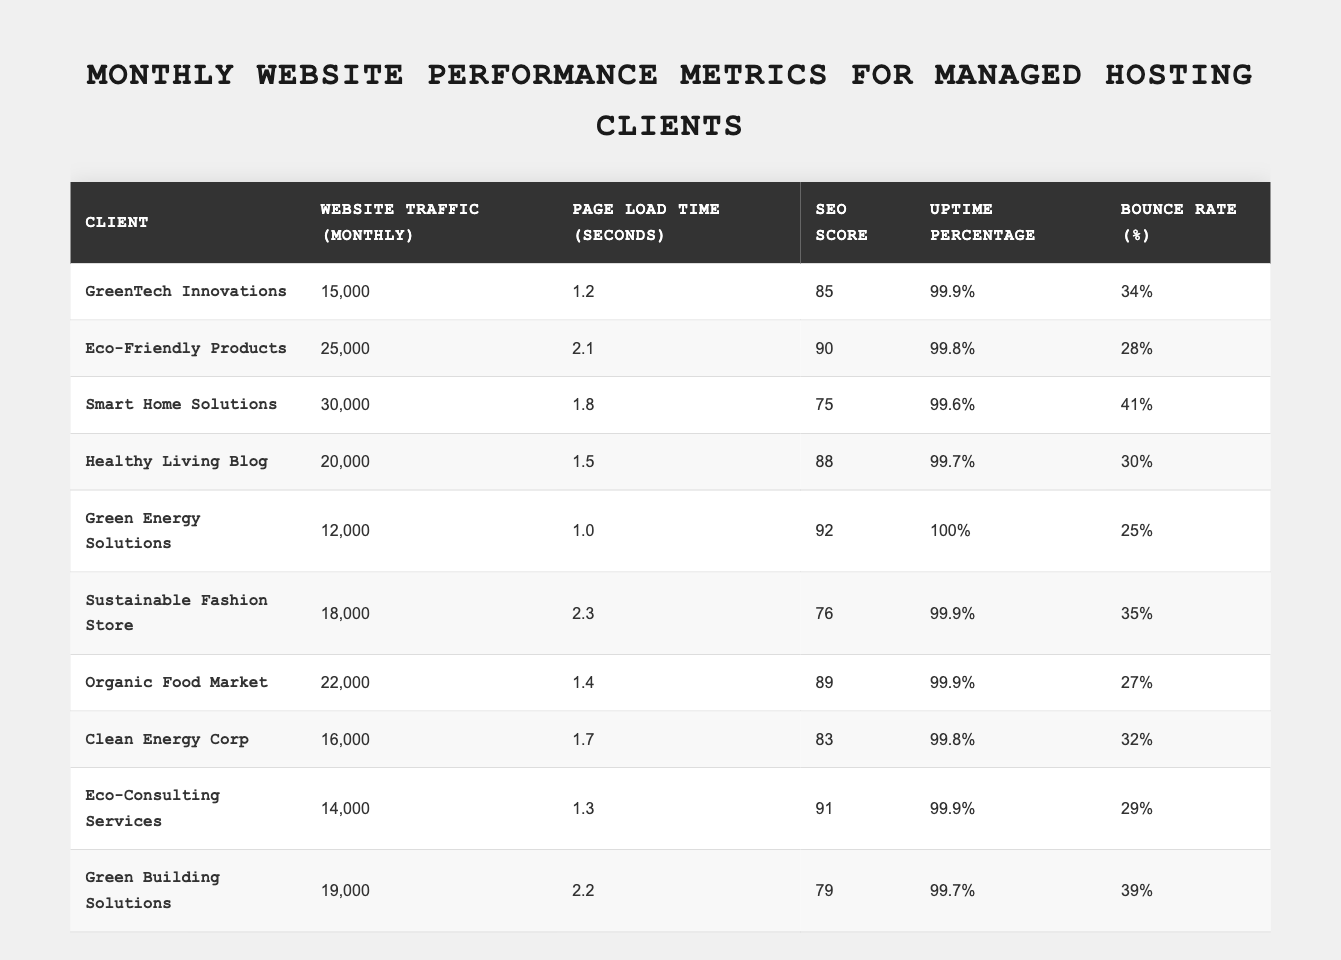What is the website traffic for GreenTech Innovations? The table lists the website traffic for GreenTech Innovations as 15,000.
Answer: 15,000 Which client has the highest SEO score? By looking at the SEO score column, Green Energy Solutions has the highest score of 92.
Answer: Green Energy Solutions What is the average page load time of all clients? To calculate the average, sum the page load times: (1.2 + 2.1 + 1.8 + 1.5 + 1.0 + 2.3 + 1.4 + 1.7 + 1.3 + 2.2) = 16.5 seconds, then divide by 10 (the number of clients), giving us an average of 1.65 seconds.
Answer: 1.65 seconds Is the uptime percentage for Smart Home Solutions greater than 99%? The uptime percentage for Smart Home Solutions is 99.6%, which is not greater than 99%.
Answer: No Which client has the lowest bounce rate? By examining the bounce rate column, Green Energy Solutions has the lowest value of 25%.
Answer: Green Energy Solutions What is the difference in website traffic between Eco-Friendly Products and Clean Energy Corp? The traffic for Eco-Friendly Products is 25,000 and for Clean Energy Corp is 16,000. The difference is 25,000 - 16,000 = 9,000.
Answer: 9,000 Which client has the fastest page load time and what is it? The fastest page load time is 1.0 seconds, which belongs to Green Energy Solutions.
Answer: Green Energy Solutions, 1.0 seconds How many clients have an uptime percentage of 99.9% or higher? From the table, Green Energy Solutions and Eco-Consulting Services have 100% and 99.9% uptime, respectively. Therefore, there are 3 clients (including them) with 99.9% or higher uptime.
Answer: 3 What is the sum of SEO scores for all clients? Adding the SEO scores: 85 + 90 + 75 + 88 + 92 + 76 + 89 + 83 + 91 + 79 =  885.
Answer: 885 Is the bounce rate for Healthy Living Blog lower than that of Organic Food Market? Healthy Living Blog has a bounce rate of 30%, while Organic Food Market has 27%. Since 30% is not lower than 27%, the answer is no.
Answer: No What is the average website traffic for clients with a bounce rate of 30% or higher? The clients with a bounce rate of 30% or higher are Smart Home Solutions (30%), Sustainable Fashion Store (35%), Green Building Solutions (39%), and others. Their traffic is 30,000 + 18,000 + 19,000 + 22,000 = 89,000. With 4 clients, the average is 89,000 / 4 = 22,250.
Answer: 22,250 Which client has the longest page load time? By inspecting the page load times, Sustainable Fashion Store has the longest load time of 2.3 seconds.
Answer: Sustainable Fashion Store 